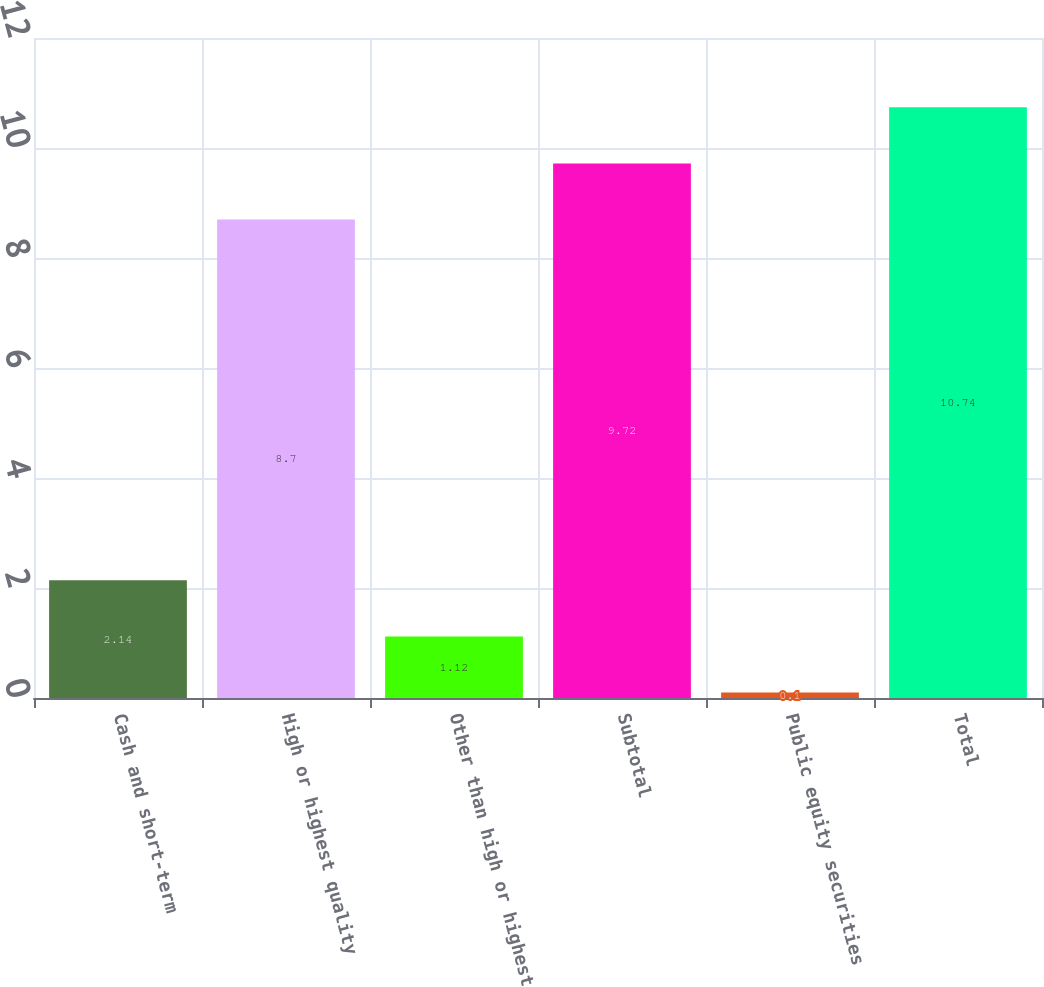<chart> <loc_0><loc_0><loc_500><loc_500><bar_chart><fcel>Cash and short-term<fcel>High or highest quality<fcel>Other than high or highest<fcel>Subtotal<fcel>Public equity securities<fcel>Total<nl><fcel>2.14<fcel>8.7<fcel>1.12<fcel>9.72<fcel>0.1<fcel>10.74<nl></chart> 